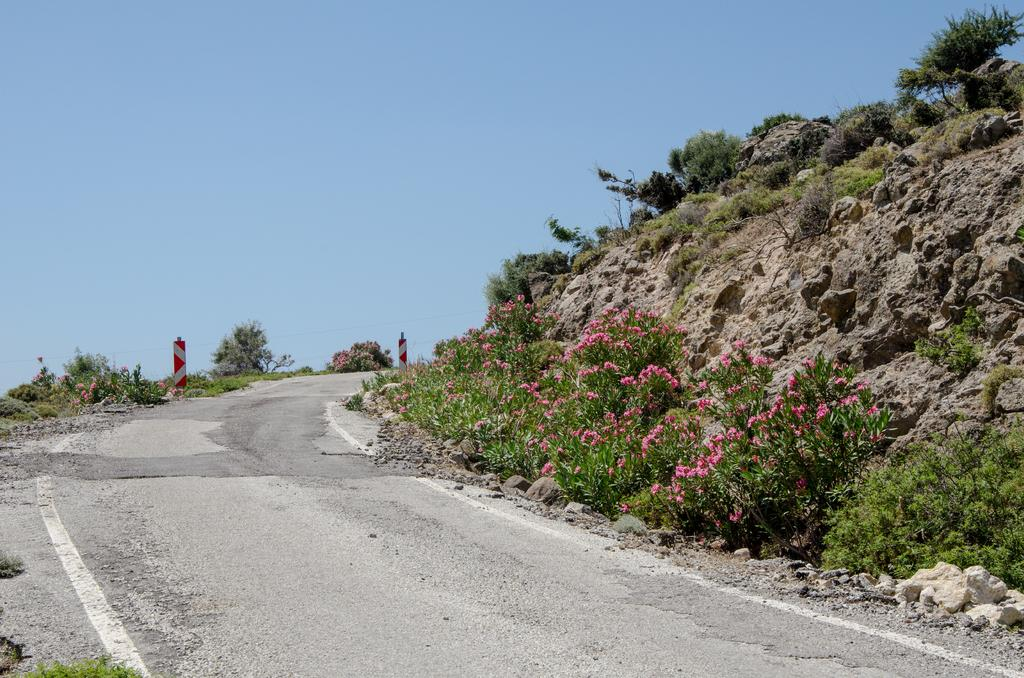What is the main feature of the image? There is a road in the image. What can be seen beside the road? There are sign boards beside the road. What type of vegetation is visible in the image? Flowers on plants are visible in the image. What else is present in the image besides the road and sign boards? Rocks are present in the image. What type of crime is being committed in the image? There is no indication of any crime being committed in the image. The image features a road, sign boards, flowers on plants, and rocks. 